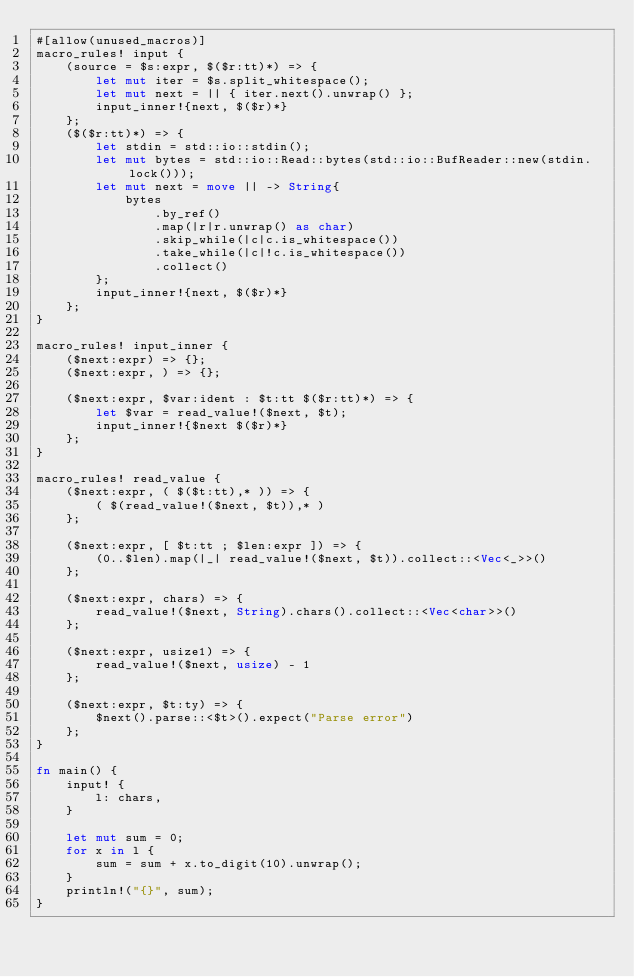Convert code to text. <code><loc_0><loc_0><loc_500><loc_500><_Rust_>#[allow(unused_macros)]
macro_rules! input {
    (source = $s:expr, $($r:tt)*) => {
        let mut iter = $s.split_whitespace();
        let mut next = || { iter.next().unwrap() };
        input_inner!{next, $($r)*}
    };
    ($($r:tt)*) => {
        let stdin = std::io::stdin();
        let mut bytes = std::io::Read::bytes(std::io::BufReader::new(stdin.lock()));
        let mut next = move || -> String{
            bytes
                .by_ref()
                .map(|r|r.unwrap() as char)
                .skip_while(|c|c.is_whitespace())
                .take_while(|c|!c.is_whitespace())
                .collect()
        };
        input_inner!{next, $($r)*}
    };
}

macro_rules! input_inner {
    ($next:expr) => {};
    ($next:expr, ) => {};

    ($next:expr, $var:ident : $t:tt $($r:tt)*) => {
        let $var = read_value!($next, $t);
        input_inner!{$next $($r)*}
    };
}

macro_rules! read_value {
    ($next:expr, ( $($t:tt),* )) => {
        ( $(read_value!($next, $t)),* )
    };

    ($next:expr, [ $t:tt ; $len:expr ]) => {
        (0..$len).map(|_| read_value!($next, $t)).collect::<Vec<_>>()
    };

    ($next:expr, chars) => {
        read_value!($next, String).chars().collect::<Vec<char>>()
    };

    ($next:expr, usize1) => {
        read_value!($next, usize) - 1
    };

    ($next:expr, $t:ty) => {
        $next().parse::<$t>().expect("Parse error")
    };
}

fn main() {
    input! {
        l: chars,
    }

    let mut sum = 0;
    for x in l {
        sum = sum + x.to_digit(10).unwrap();
    }
    println!("{}", sum);
}
</code> 